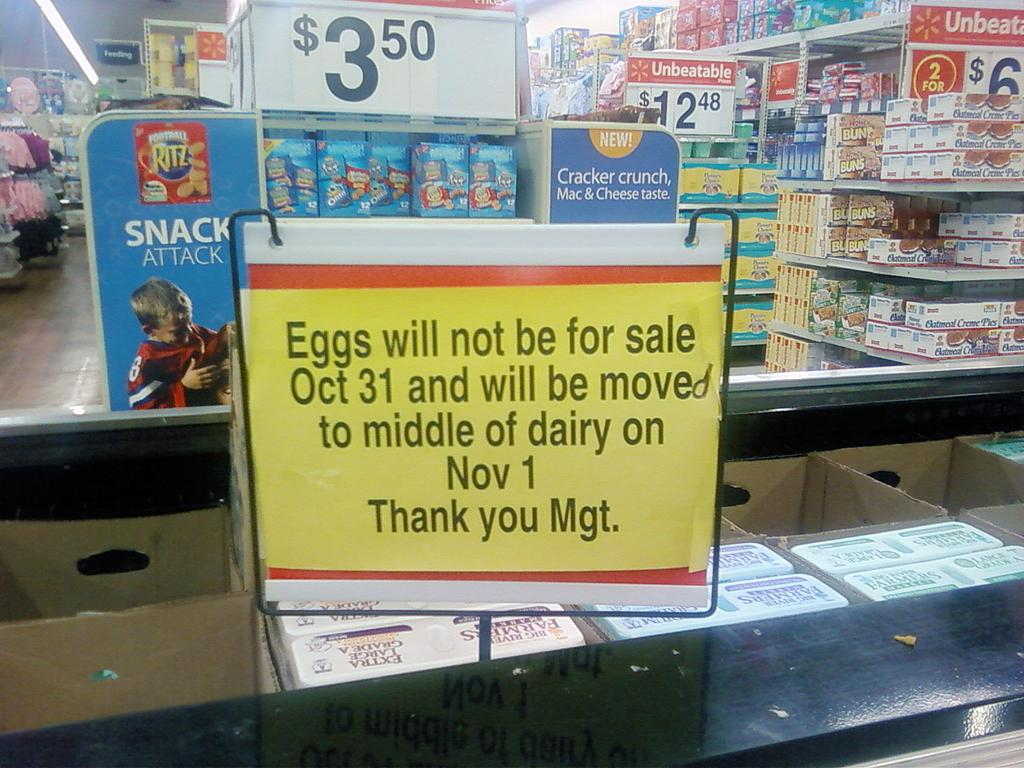<image>
Relay a brief, clear account of the picture shown. Sign in front of eggs that says that the eggs will not be for sale. 